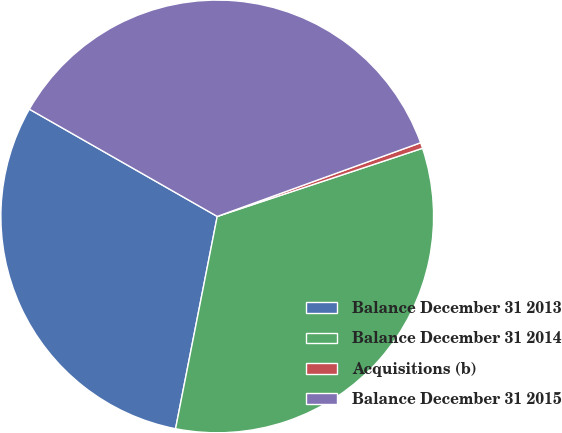Convert chart to OTSL. <chart><loc_0><loc_0><loc_500><loc_500><pie_chart><fcel>Balance December 31 2013<fcel>Balance December 31 2014<fcel>Acquisitions (b)<fcel>Balance December 31 2015<nl><fcel>30.17%<fcel>33.19%<fcel>0.43%<fcel>36.21%<nl></chart> 